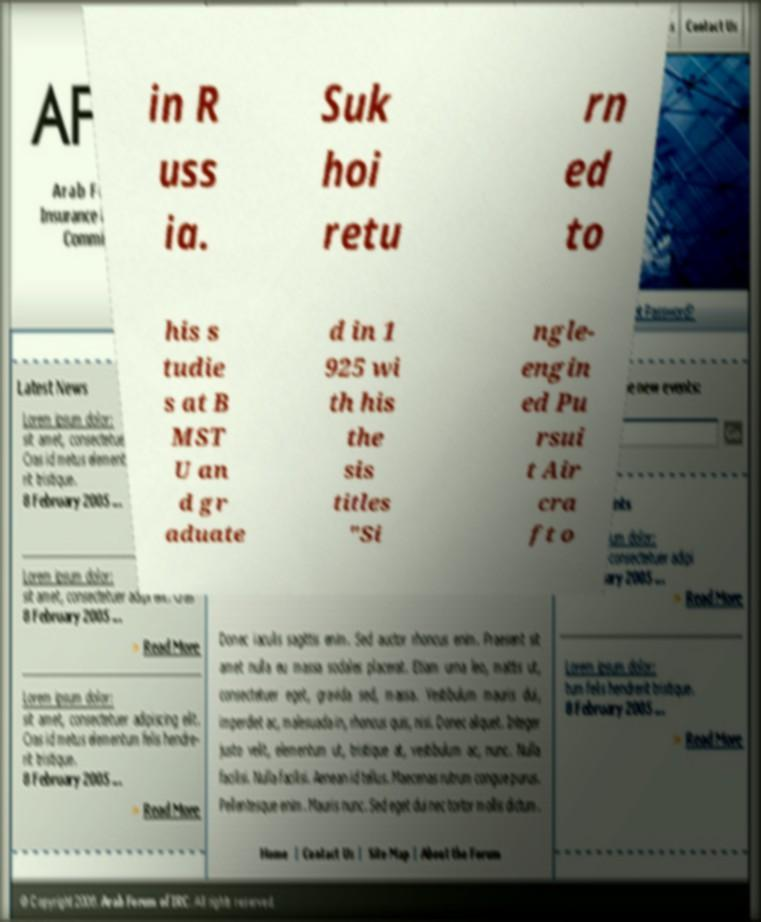Can you accurately transcribe the text from the provided image for me? in R uss ia. Suk hoi retu rn ed to his s tudie s at B MST U an d gr aduate d in 1 925 wi th his the sis titles "Si ngle- engin ed Pu rsui t Air cra ft o 